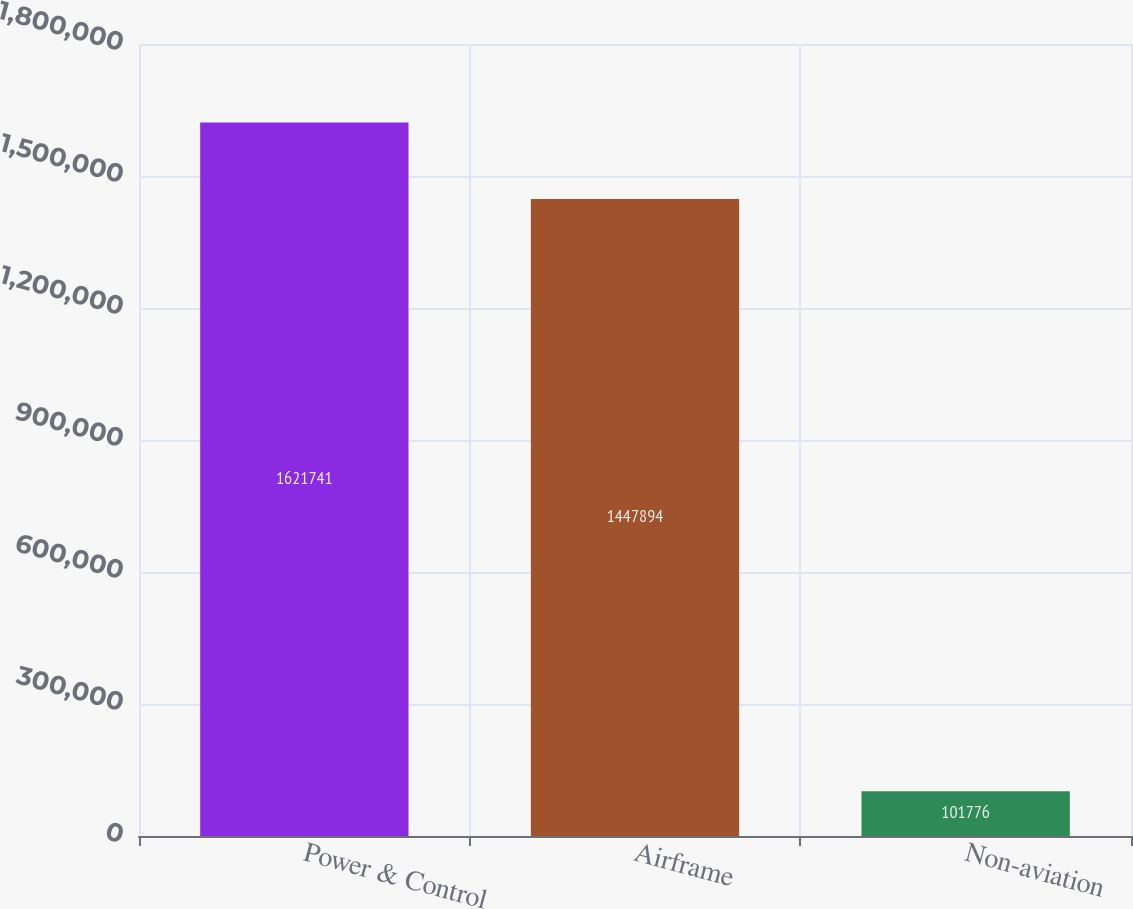Convert chart. <chart><loc_0><loc_0><loc_500><loc_500><bar_chart><fcel>Power & Control<fcel>Airframe<fcel>Non-aviation<nl><fcel>1.62174e+06<fcel>1.44789e+06<fcel>101776<nl></chart> 